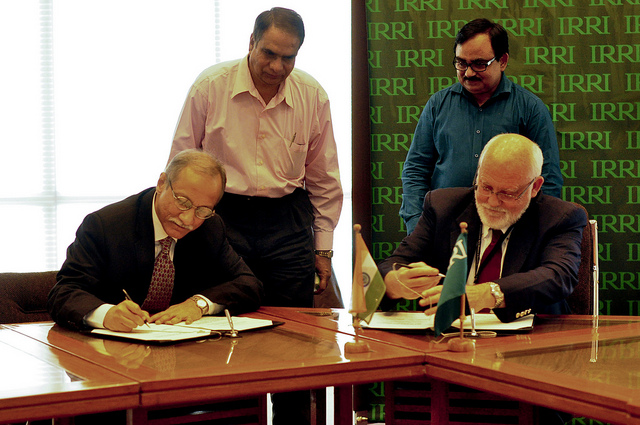Please identify all text content in this image. IRRI IRRI IRRI RI RI RR D I IR IR RI R IRR IR IRRI IR RI IRR RI IRR IR IRRI RI IR IRRI RI IR IR IRRI IR RRI IR IRRI IRRI IRRI RI 